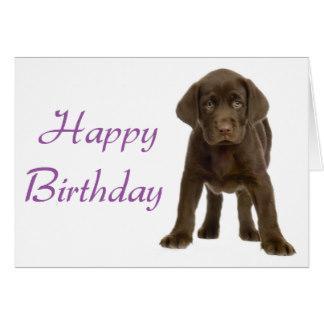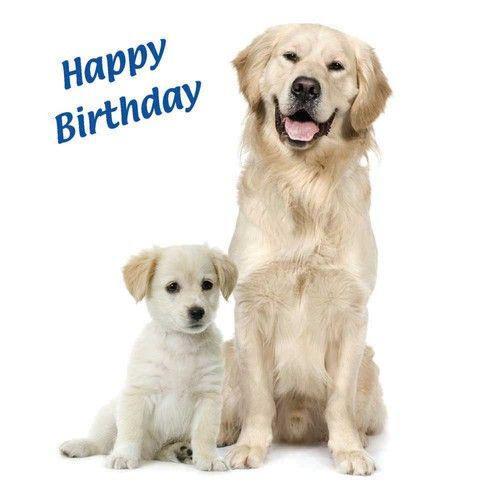The first image is the image on the left, the second image is the image on the right. Given the left and right images, does the statement "there are five dogs in the image on the right." hold true? Answer yes or no. No. The first image is the image on the left, the second image is the image on the right. Evaluate the accuracy of this statement regarding the images: "One image shows exactly two puppies, including a black one.". Is it true? Answer yes or no. No. 